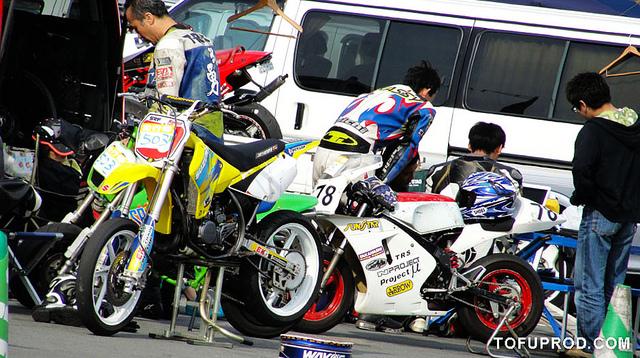How much do those safety helmets weigh?
Keep it brief. 1 pound. What number is on the white bike?
Answer briefly. 18. What keeps the motorcycles upright?
Quick response, please. Kickstand. 